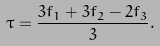Convert formula to latex. <formula><loc_0><loc_0><loc_500><loc_500>\tau = \frac { 3 f _ { 1 } + 3 f _ { 2 } - 2 f _ { 3 } } { 3 } .</formula> 